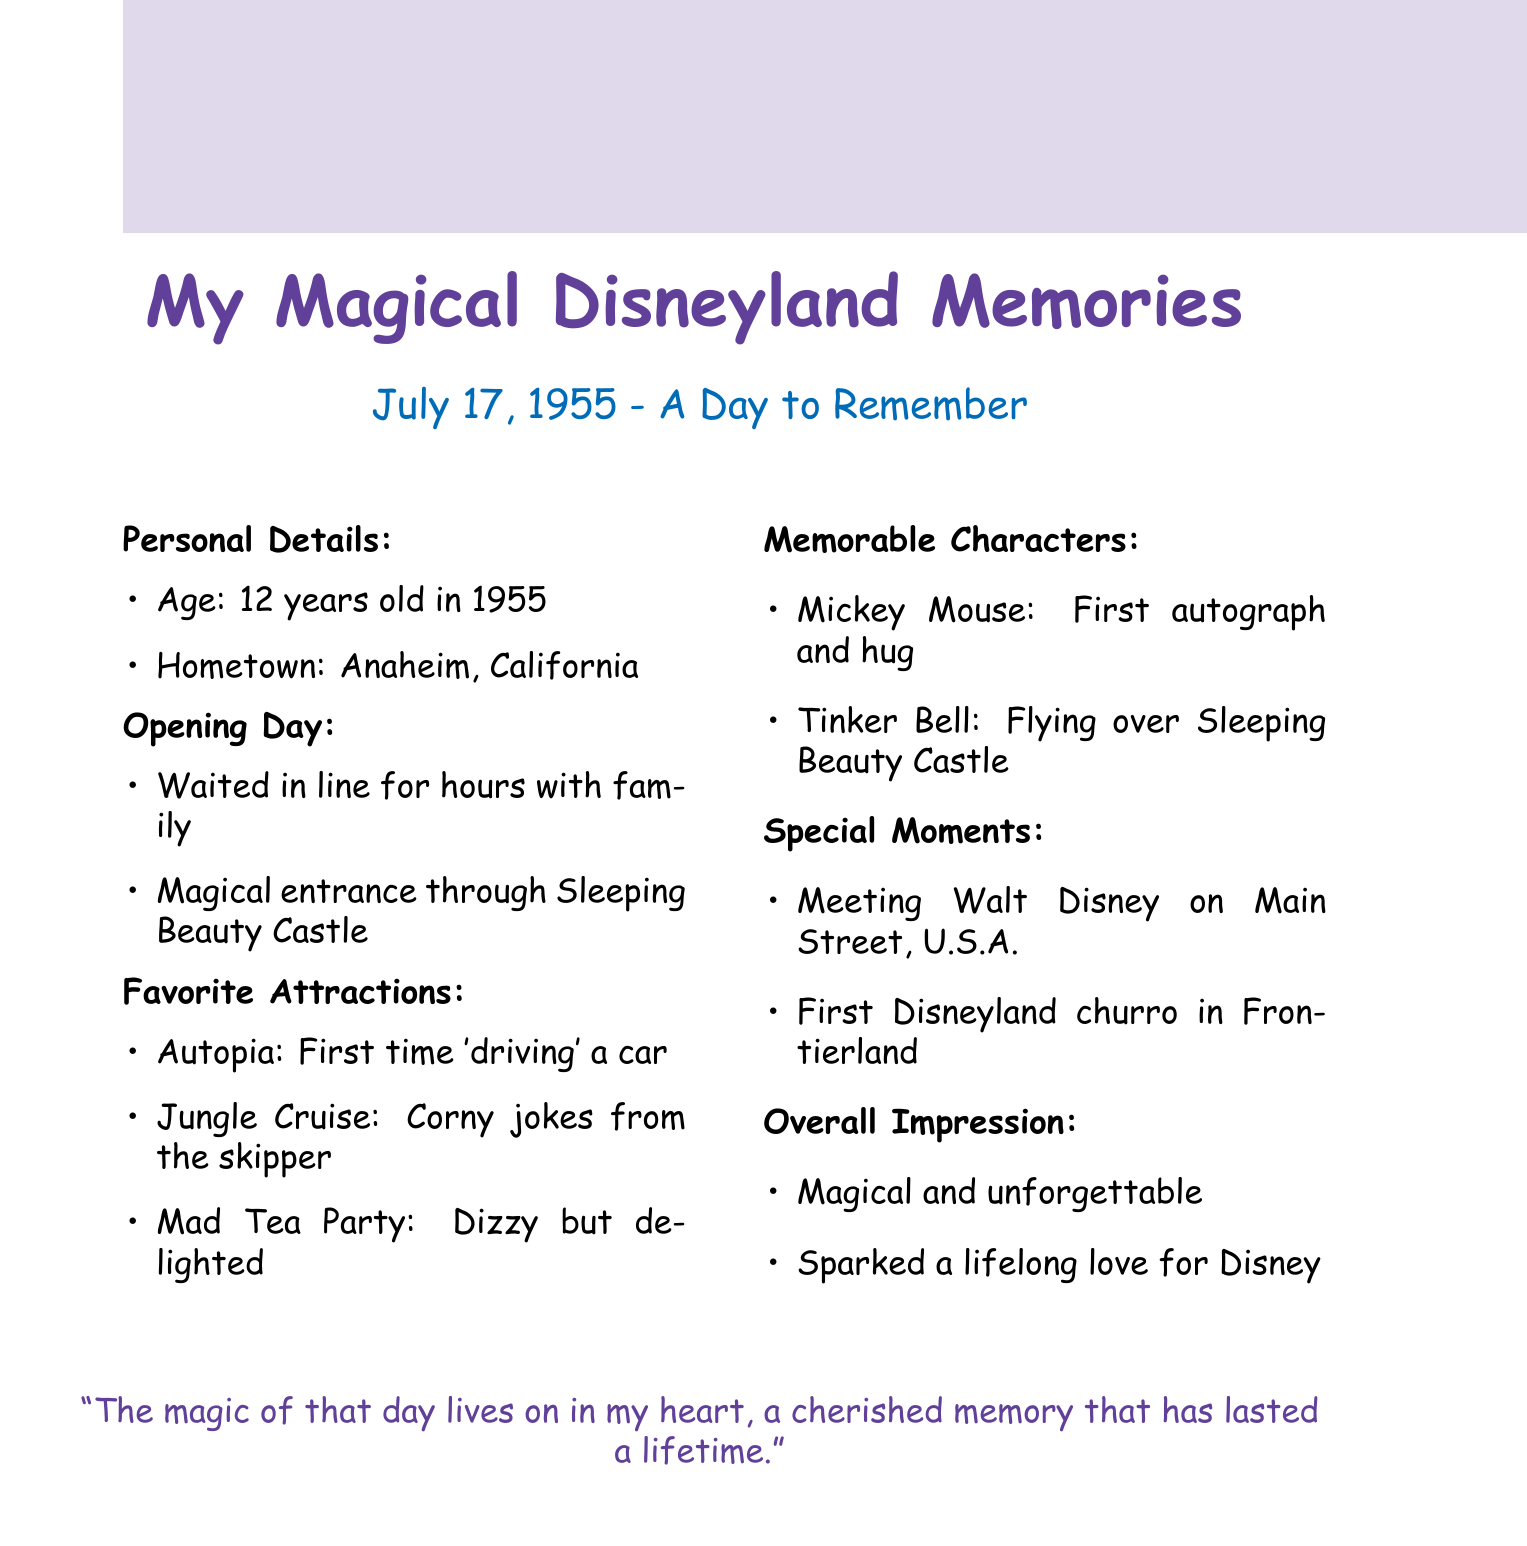What was the date of the opening day at Disneyland? The date of the opening day is specified as July 17, 1955.
Answer: July 17, 1955 How old was the author during the first visit to Disneyland? The author's age during the first visit is mentioned as 12 years old in 1955.
Answer: 12 years old What was the first attraction mentioned that the author rode? The first attraction mentioned as 'driving' a car is Autopia.
Answer: Autopia Which character gave the author their first autograph? The character that gave the author their first autograph was Mickey Mouse.
Answer: Mickey Mouse What food item was highlighted as a special moment? The food item highlighted as a special moment was the first Disneyland churro.
Answer: First Disneyland churro What was the author's overall impression of the visit? The author's overall impression is described as magical and unforgettable.
Answer: Magical and unforgettable Where did the author meet Walt Disney? The location where the author met Walt Disney is Main Street, U.S.A.
Answer: Main Street, U.S.A What did the author experience in the Mad Tea Party? The experience in the Mad Tea Party is described as dizzy but delighted.
Answer: Dizzy but delighted 